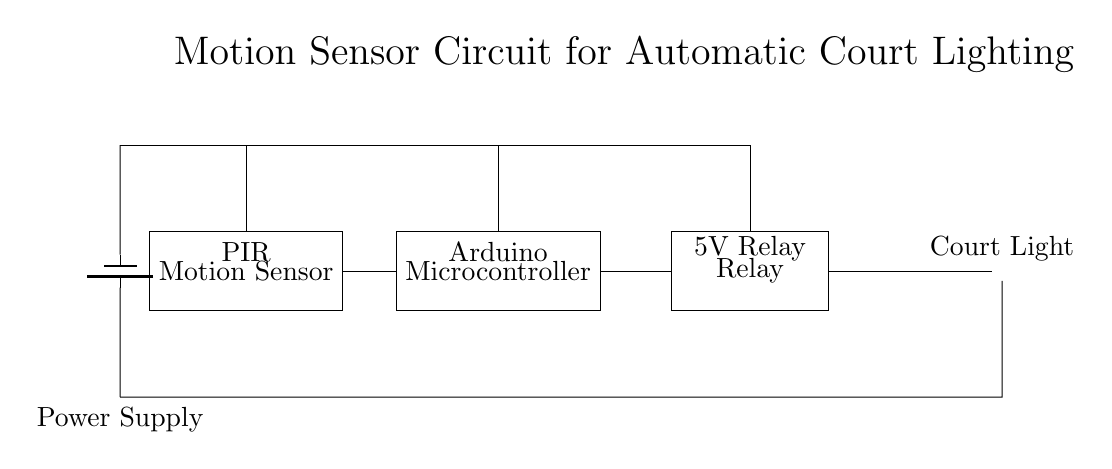What type of sensor is used in this circuit? The circuit diagram shows a PIR sensor, which is a type of motion sensor that detects changes in infrared radiation. This sensor is positioned at the leftmost part of the diagram, labeled as "Motion Sensor" with "PIR" above it.
Answer: PIR What is the primary function of the microcontroller in this circuit? The microcontroller, labeled "Arduino," is responsible for processing the signals received from the motion sensor and controlling the relay to turn the court light on or off based on motion detection. It is positioned in the center of the circuit diagram and connects to both the sensor and the relay.
Answer: Processing How is power supplied to the components in this circuit? The circuit receives power from a battery, indicated by the "Power Supply" label at the top left. The power is routed to each of the main components: the sensor, the microcontroller, and the relay, ensuring they operate correctly when motion is detected.
Answer: Battery What type of relay is used in this circuit? The relay is a 5V relay, as indicated by the label above it in the diagram. This relay acts as a switch that controls the court light based on the commands sent from the microcontroller.
Answer: 5V Relay How does the motion sensing mechanism initiate the lighting? When motion is detected by the PIR sensor, it sends a signal to the microcontroller (Arduino), which then activates the relay to turn on the court light. This sequence of detection and actuation creates the automatic lighting feature.
Answer: Signal Activation What is the ultimate load or device that is being controlled in this circuit? The court light, indicated by the lamp symbol at the far right, is the device being controlled in this circuit. It is designed to turn on when the relay is activated by the microcontroller based on the PIR sensor's input.
Answer: Court Light 